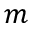<formula> <loc_0><loc_0><loc_500><loc_500>m</formula> 